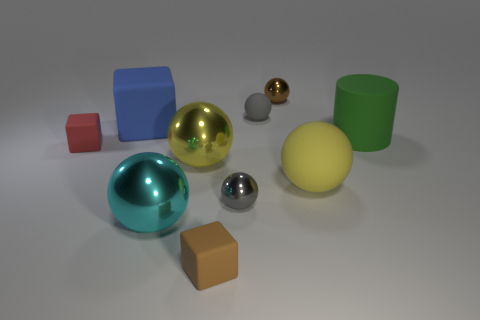Are there fewer large matte balls left of the gray metallic thing than blue things?
Your answer should be compact. Yes. Is the color of the big cylinder the same as the small rubber ball?
Offer a very short reply. No. There is a blue rubber object that is the same shape as the small red thing; what is its size?
Your answer should be compact. Large. What number of large yellow things have the same material as the brown ball?
Make the answer very short. 1. Is the material of the small brown object behind the big cube the same as the green thing?
Offer a terse response. No. Are there the same number of large green matte cylinders to the left of the gray metallic object and large cyan spheres?
Offer a very short reply. No. What is the size of the yellow metal thing?
Ensure brevity in your answer.  Large. There is another big ball that is the same color as the large rubber sphere; what is it made of?
Ensure brevity in your answer.  Metal. What number of other matte spheres are the same color as the large matte sphere?
Give a very brief answer. 0. Is the brown block the same size as the blue cube?
Provide a succinct answer. No. 